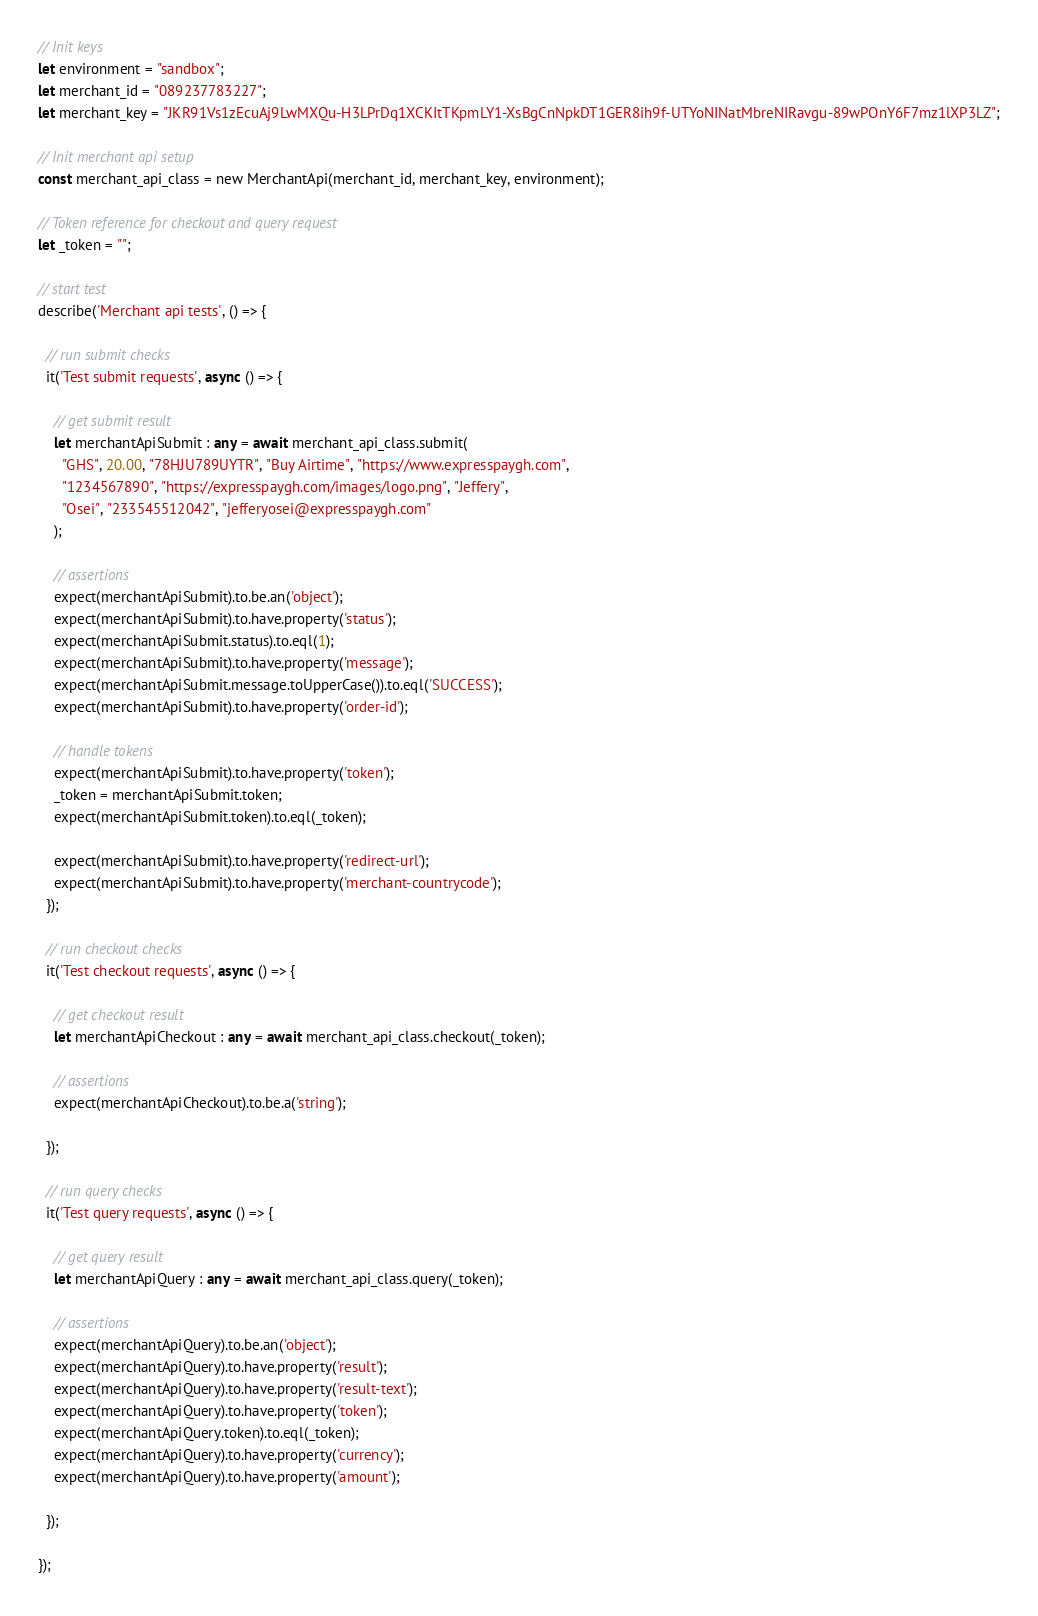<code> <loc_0><loc_0><loc_500><loc_500><_TypeScript_>
// Init keys
let environment = "sandbox";
let merchant_id = "089237783227";
let merchant_key = "JKR91Vs1zEcuAj9LwMXQu-H3LPrDq1XCKItTKpmLY1-XsBgCnNpkDT1GER8ih9f-UTYoNINatMbreNIRavgu-89wPOnY6F7mz1lXP3LZ";

// Init merchant api setup
const merchant_api_class = new MerchantApi(merchant_id, merchant_key, environment);

// Token reference for checkout and query request
let _token = "";

// start test
describe('Merchant api tests', () => {

  // run submit checks
  it('Test submit requests', async () => {

    // get submit result
    let merchantApiSubmit : any = await merchant_api_class.submit(
      "GHS", 20.00, "78HJU789UYTR", "Buy Airtime", "https://www.expresspaygh.com",
      "1234567890", "https://expresspaygh.com/images/logo.png", "Jeffery", 
      "Osei", "233545512042", "jefferyosei@expresspaygh.com"
    );

    // assertions
    expect(merchantApiSubmit).to.be.an('object');
    expect(merchantApiSubmit).to.have.property('status');
    expect(merchantApiSubmit.status).to.eql(1);
    expect(merchantApiSubmit).to.have.property('message');
    expect(merchantApiSubmit.message.toUpperCase()).to.eql('SUCCESS');
    expect(merchantApiSubmit).to.have.property('order-id');

    // handle tokens
    expect(merchantApiSubmit).to.have.property('token');
    _token = merchantApiSubmit.token;
    expect(merchantApiSubmit.token).to.eql(_token);

    expect(merchantApiSubmit).to.have.property('redirect-url');
    expect(merchantApiSubmit).to.have.property('merchant-countrycode');
  });

  // run checkout checks
  it('Test checkout requests', async () => {

    // get checkout result
    let merchantApiCheckout : any = await merchant_api_class.checkout(_token);
    
    // assertions
    expect(merchantApiCheckout).to.be.a('string');

  });

  // run query checks
  it('Test query requests', async () => {

    // get query result
    let merchantApiQuery : any = await merchant_api_class.query(_token);
    
    // assertions
    expect(merchantApiQuery).to.be.an('object');
    expect(merchantApiQuery).to.have.property('result');
    expect(merchantApiQuery).to.have.property('result-text');
    expect(merchantApiQuery).to.have.property('token');
    expect(merchantApiQuery.token).to.eql(_token);
    expect(merchantApiQuery).to.have.property('currency');
    expect(merchantApiQuery).to.have.property('amount');

  });
  
});
</code> 